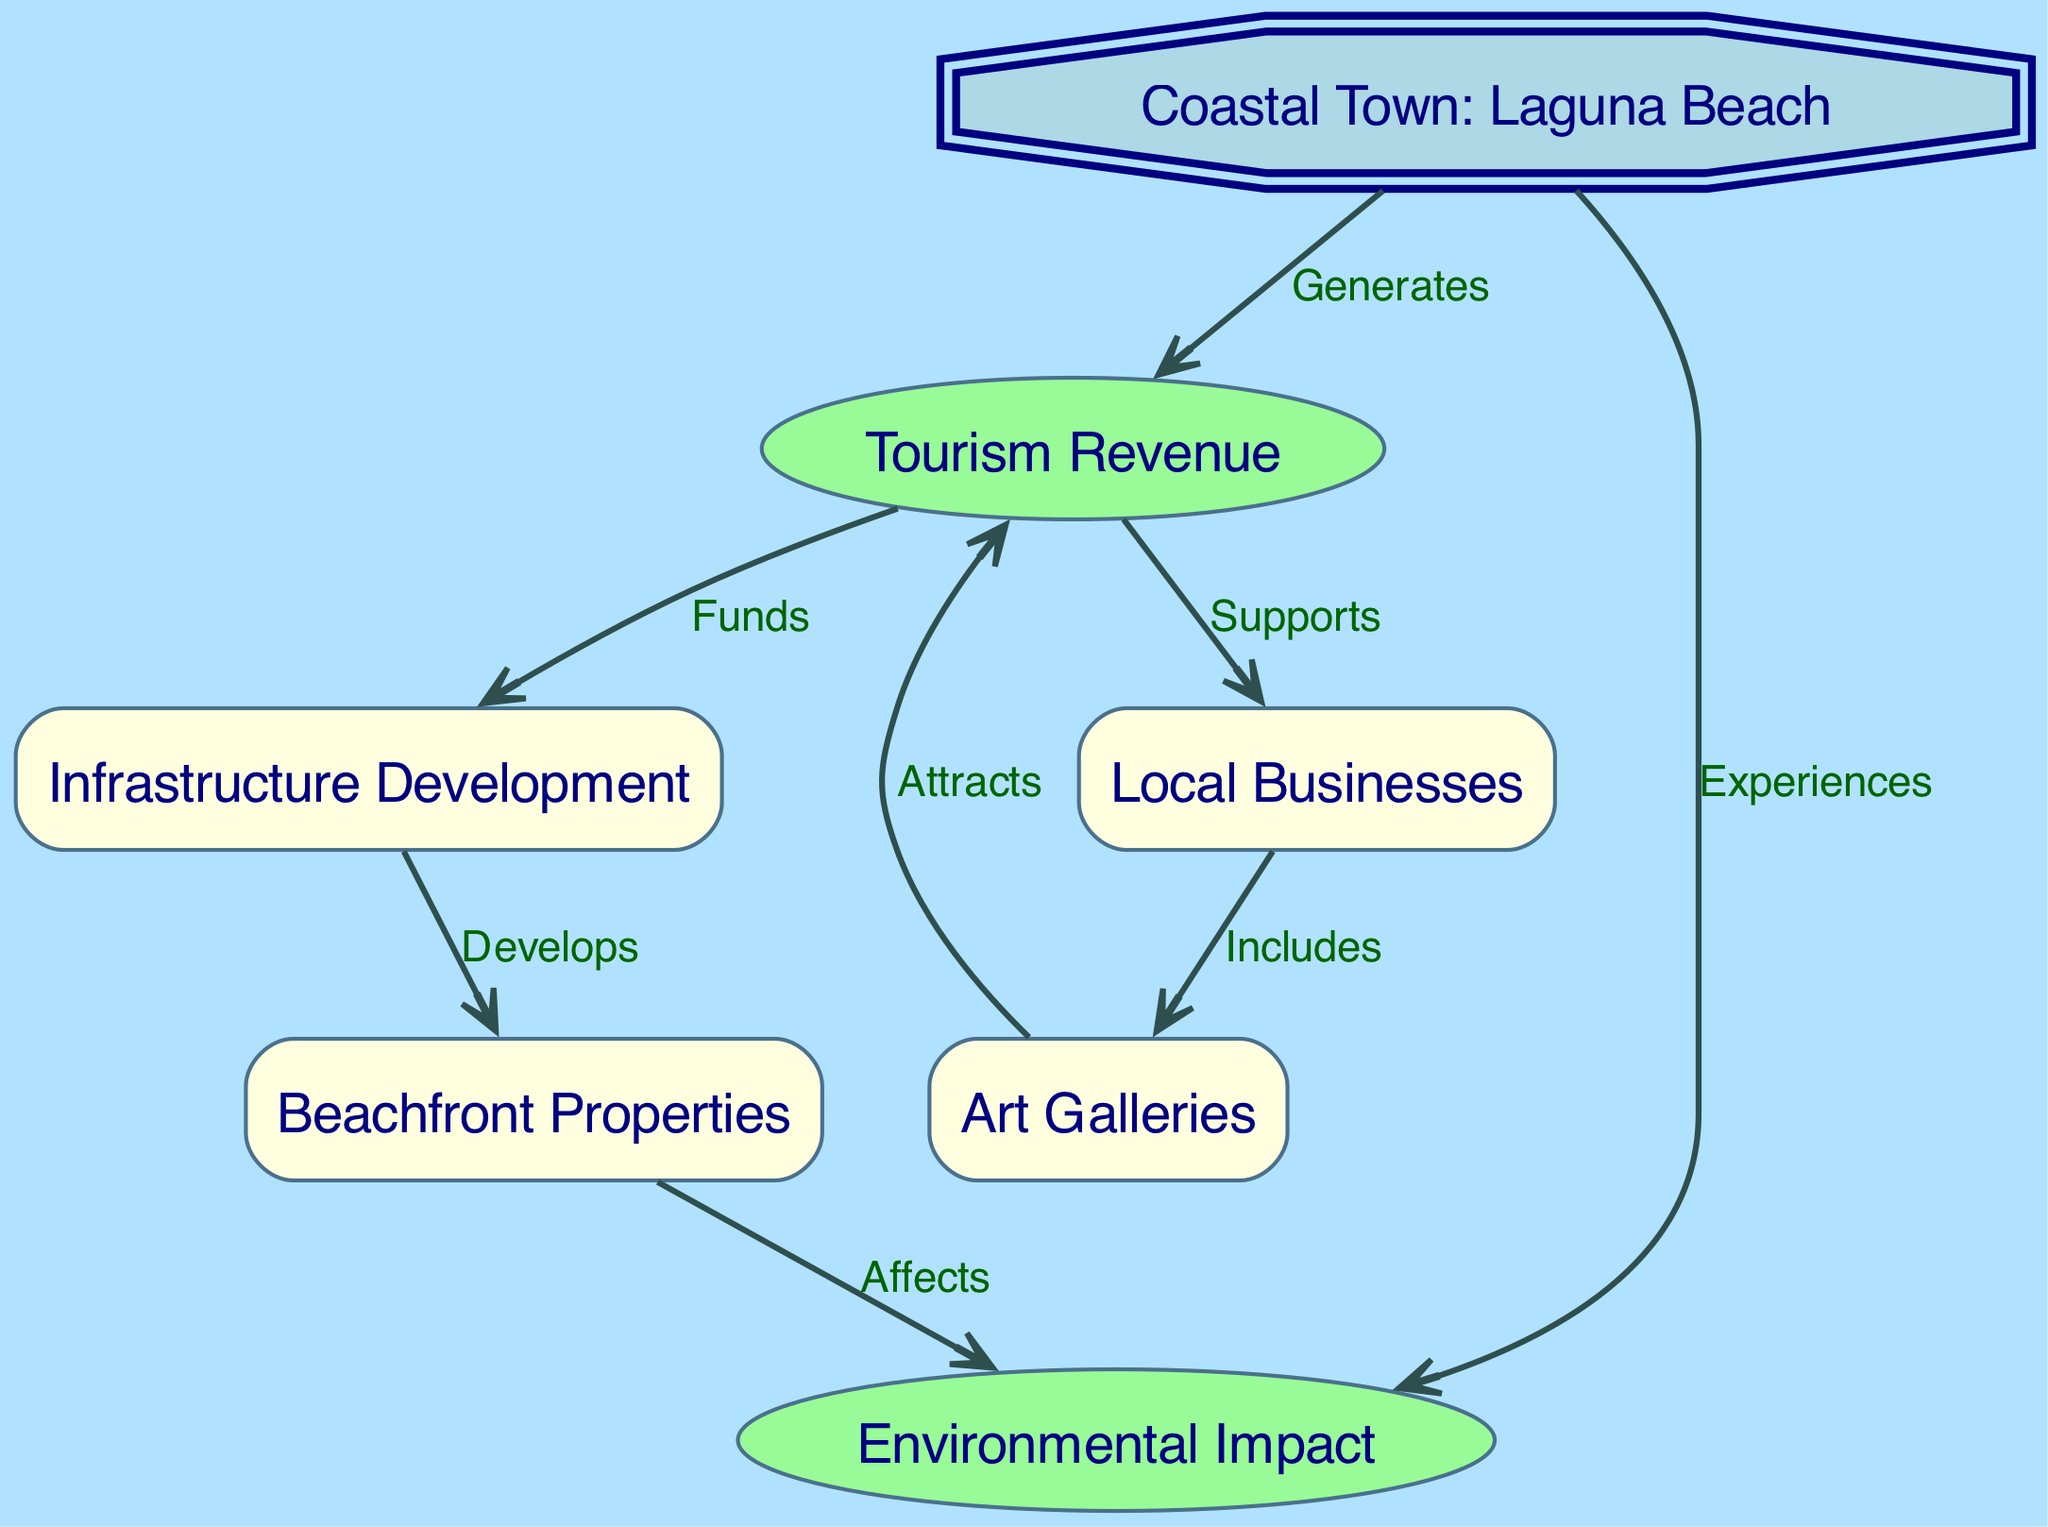What is the primary source of revenue for Laguna Beach? The diagram indicates that Tourism Revenue is generated by the Coastal Town, as it directly connects to the node labeled "Coastal Town: Laguna Beach" with the label "Generates."
Answer: Tourism Revenue How many nodes are present in the diagram? By counting the nodes listed in the diagram, we find there are a total of 7 nodes representing different aspects related to tourism's impact.
Answer: 7 What type of businesses are supported by tourism revenue? The diagram shows that Local Businesses are supported by Tourism Revenue as indicated by the edge connecting these two nodes with the label "Supports."
Answer: Local Businesses Which node affects the environmental impact? The diagram reveals that Beachfront Properties affect the Environmental Impact, as the edge between these two nodes is labeled "Affects."
Answer: Beachfront Properties How does tourism revenue contribute to the development of infrastructure? In the diagram, it is shown that the Tourism RevenueFunds the Infrastructure Development, as there is a directed edge labeled "Funds" from Tourism Revenue to Infrastructure Development.
Answer: Funds How does the presence of art galleries influence tourism? The diagram indicates that Art Galleries attract Tourism Revenue, based on the directed edge connecting these two nodes with the label "Attracts."
Answer: Attracts What is the relationship between infrastructure development and beachfront properties? The diagram demonstrates that Infrastructure Development develops Beachfront Properties, as reflected in the directed edge labeled "Develops."
Answer: Develops What experiences does the coastal town experience due to tourism? According to the diagram, the Coastal Town experiences Environmental Impact stemming from tourism, as indicated by the edge labeled "Experiences" connecting these two nodes.
Answer: Environmental Impact Which factor funds local businesses as per the diagram? The diagram specifies that Tourism Revenue funds Local Businesses, shown by the connection with the label "Supports" from Tourism Revenue to Local Businesses.
Answer: Supports 